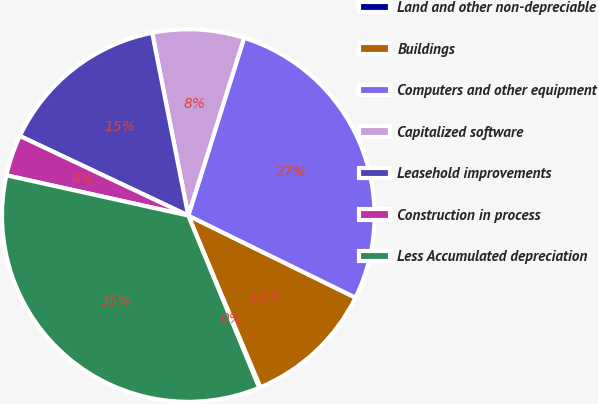<chart> <loc_0><loc_0><loc_500><loc_500><pie_chart><fcel>Land and other non-depreciable<fcel>Buildings<fcel>Computers and other equipment<fcel>Capitalized software<fcel>Leasehold improvements<fcel>Construction in process<fcel>Less Accumulated depreciation<nl><fcel>0.11%<fcel>11.41%<fcel>27.42%<fcel>7.95%<fcel>14.87%<fcel>3.56%<fcel>34.69%<nl></chart> 